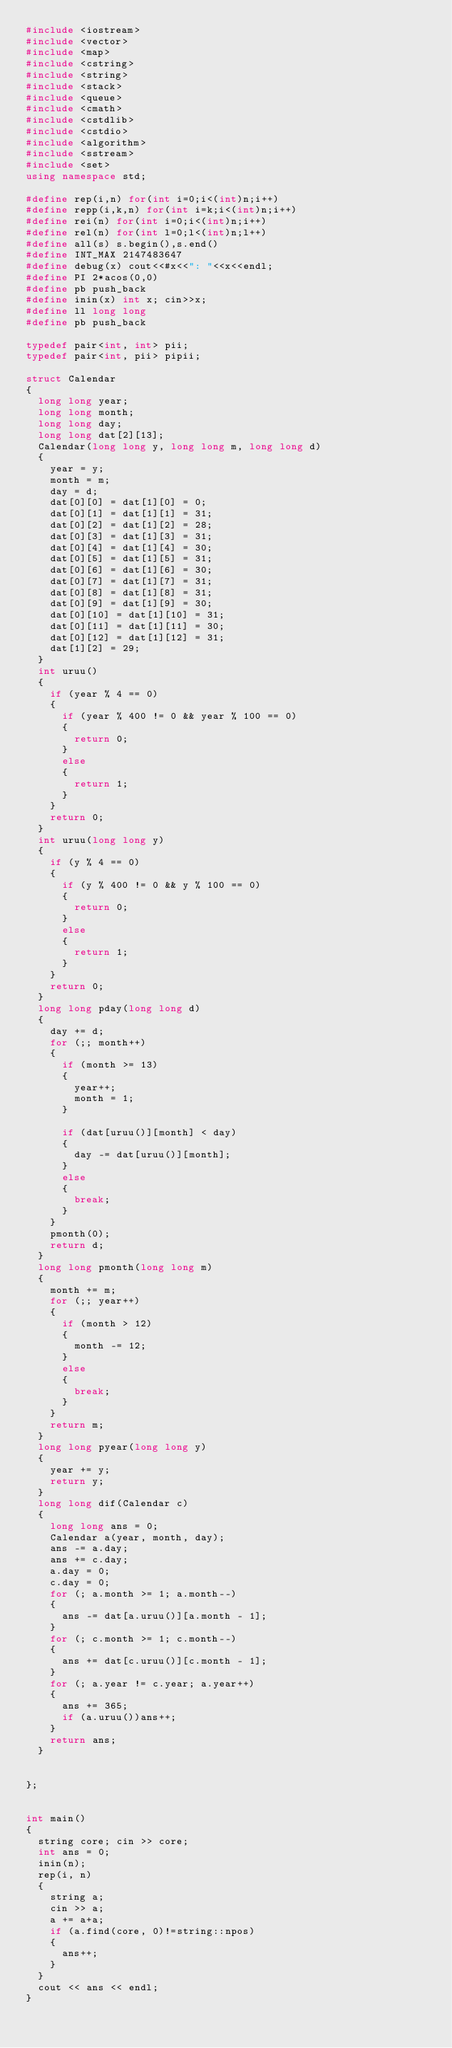<code> <loc_0><loc_0><loc_500><loc_500><_C++_>#include <iostream>
#include <vector>
#include <map>
#include <cstring>
#include <string>
#include <stack>
#include <queue>
#include <cmath>
#include <cstdlib>
#include <cstdio>
#include <algorithm>
#include <sstream>
#include <set>
using namespace std;

#define rep(i,n) for(int i=0;i<(int)n;i++)
#define repp(i,k,n) for(int i=k;i<(int)n;i++)
#define rei(n) for(int i=0;i<(int)n;i++)
#define rel(n) for(int l=0;l<(int)n;l++)
#define all(s) s.begin(),s.end()
#define INT_MAX 2147483647
#define debug(x) cout<<#x<<": "<<x<<endl;
#define PI 2*acos(0,0)
#define pb push_back
#define inin(x) int x; cin>>x;
#define ll long long
#define pb push_back

typedef pair<int, int> pii;
typedef pair<int, pii> pipii;

struct Calendar
{
	long long year;
	long long month;
	long long day;
	long long dat[2][13];
	Calendar(long long y, long long m, long long d)
	{
		year = y;
		month = m;
		day = d;
		dat[0][0] = dat[1][0] = 0;
		dat[0][1] = dat[1][1] = 31;
		dat[0][2] = dat[1][2] = 28;
		dat[0][3] = dat[1][3] = 31;
		dat[0][4] = dat[1][4] = 30;
		dat[0][5] = dat[1][5] = 31;
		dat[0][6] = dat[1][6] = 30;
		dat[0][7] = dat[1][7] = 31;
		dat[0][8] = dat[1][8] = 31;
		dat[0][9] = dat[1][9] = 30;
		dat[0][10] = dat[1][10] = 31;
		dat[0][11] = dat[1][11] = 30;
		dat[0][12] = dat[1][12] = 31;
		dat[1][2] = 29;
	}
	int uruu()
	{
		if (year % 4 == 0)
		{
			if (year % 400 != 0 && year % 100 == 0)
			{
				return 0;
			}
			else
			{
				return 1;
			}
		}
		return 0;
	}
	int uruu(long long y)
	{
		if (y % 4 == 0)
		{
			if (y % 400 != 0 && y % 100 == 0)
			{
				return 0;
			}
			else
			{
				return 1;
			}
		}
		return 0;
	}
	long long pday(long long d)
	{
		day += d;
		for (;; month++)
		{
			if (month >= 13)
			{
				year++;
				month = 1;
			}

			if (dat[uruu()][month] < day)
			{
				day -= dat[uruu()][month];
			}
			else
			{
				break;
			}
		}
		pmonth(0);
		return d;
	}
	long long pmonth(long long m)
	{
		month += m;
		for (;; year++)
		{
			if (month > 12)
			{
				month -= 12;
			}
			else
			{
				break;
			}
		}
		return m;
	}
	long long pyear(long long y)
	{
		year += y;
		return y;
	}
	long long dif(Calendar c)
	{
		long long ans = 0;
		Calendar a(year, month, day);
		ans -= a.day;
		ans += c.day;
		a.day = 0;
		c.day = 0;
		for (; a.month >= 1; a.month--)
		{
			ans -= dat[a.uruu()][a.month - 1];
		}
		for (; c.month >= 1; c.month--)
		{
			ans += dat[c.uruu()][c.month - 1];
		}
		for (; a.year != c.year; a.year++)
		{
			ans += 365;
			if (a.uruu())ans++;
		}
		return ans;
	}


};


int main()
{
	string core; cin >> core;
	int ans = 0;
	inin(n);
	rep(i, n)
	{
		string a;
		cin >> a;
		a += a+a;
		if (a.find(core, 0)!=string::npos)
		{
			ans++;
		}
	}
	cout << ans << endl;
}</code> 